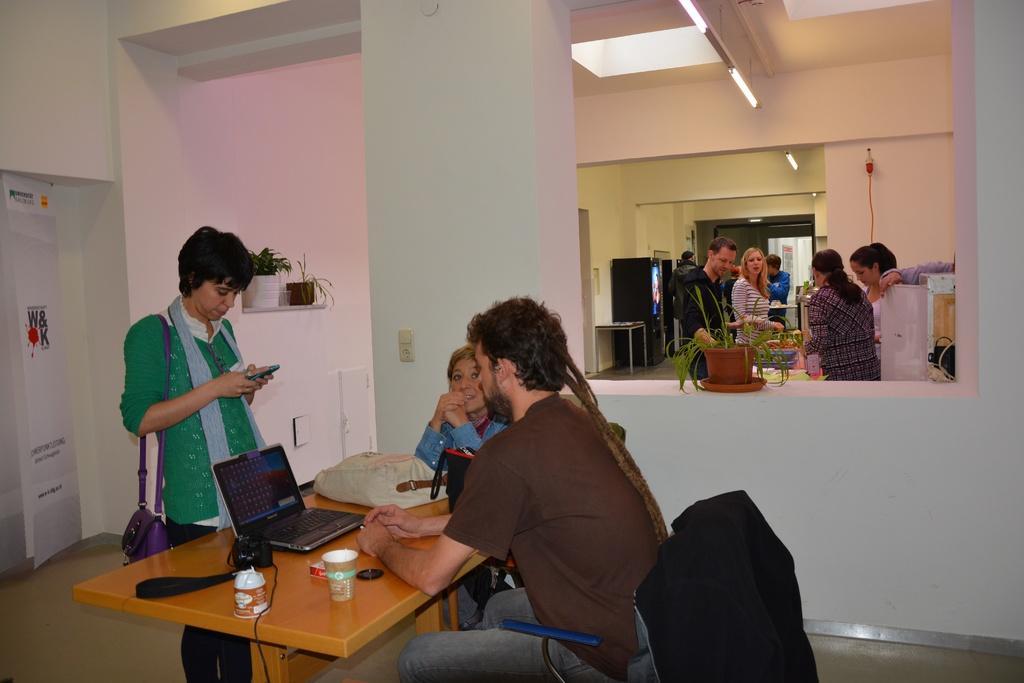How would you summarize this image in a sentence or two? In the picture it is a closed room at the right corner of the picture there are four people standing and behind them other two people are standing. In another room there are two people are sitting on the chairs in front of the table and one laptop, cups present on the table and in the left corner of the picture one woman is standing and carrying a sling bag with her in a green dress behind her there is a white wall and a poster and behind her there are some plants. 